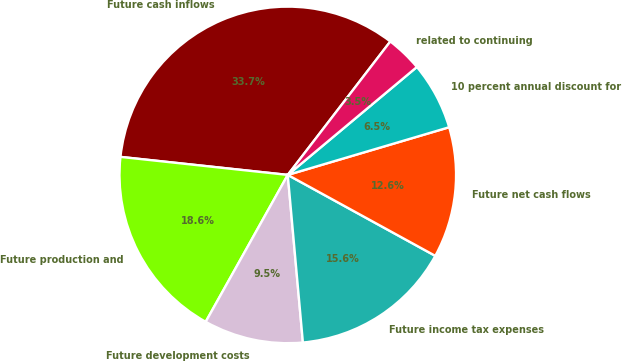Convert chart. <chart><loc_0><loc_0><loc_500><loc_500><pie_chart><fcel>Future cash inflows<fcel>Future production and<fcel>Future development costs<fcel>Future income tax expenses<fcel>Future net cash flows<fcel>10 percent annual discount for<fcel>related to continuing<nl><fcel>33.72%<fcel>18.6%<fcel>9.54%<fcel>15.58%<fcel>12.56%<fcel>6.51%<fcel>3.49%<nl></chart> 